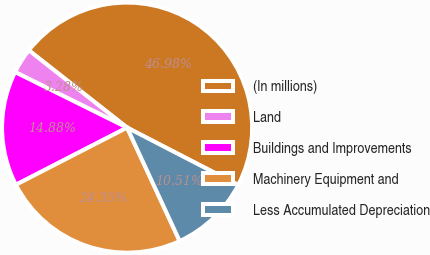Convert chart. <chart><loc_0><loc_0><loc_500><loc_500><pie_chart><fcel>(In millions)<fcel>Land<fcel>Buildings and Improvements<fcel>Machinery Equipment and<fcel>Less Accumulated Depreciation<nl><fcel>46.98%<fcel>3.28%<fcel>14.88%<fcel>24.35%<fcel>10.51%<nl></chart> 